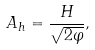<formula> <loc_0><loc_0><loc_500><loc_500>A _ { h } = \frac { H } { \sqrt { 2 \varphi } } ,</formula> 